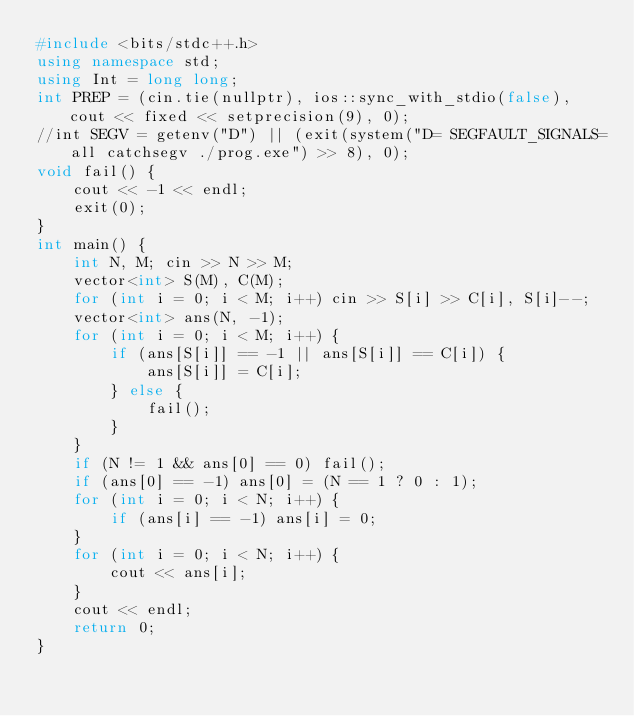Convert code to text. <code><loc_0><loc_0><loc_500><loc_500><_C++_>#include <bits/stdc++.h>
using namespace std;
using Int = long long;
int PREP = (cin.tie(nullptr), ios::sync_with_stdio(false), cout << fixed << setprecision(9), 0);
//int SEGV = getenv("D") || (exit(system("D= SEGFAULT_SIGNALS=all catchsegv ./prog.exe") >> 8), 0);
void fail() {
    cout << -1 << endl;
    exit(0);
}
int main() {
    int N, M; cin >> N >> M;
    vector<int> S(M), C(M);
    for (int i = 0; i < M; i++) cin >> S[i] >> C[i], S[i]--;
    vector<int> ans(N, -1);
    for (int i = 0; i < M; i++) {
        if (ans[S[i]] == -1 || ans[S[i]] == C[i]) {
            ans[S[i]] = C[i];
        } else {
            fail();
        }
    }
    if (N != 1 && ans[0] == 0) fail();
    if (ans[0] == -1) ans[0] = (N == 1 ? 0 : 1);
    for (int i = 0; i < N; i++) {
        if (ans[i] == -1) ans[i] = 0;
    }
    for (int i = 0; i < N; i++) {
        cout << ans[i];
    }
    cout << endl;
    return 0;
}</code> 